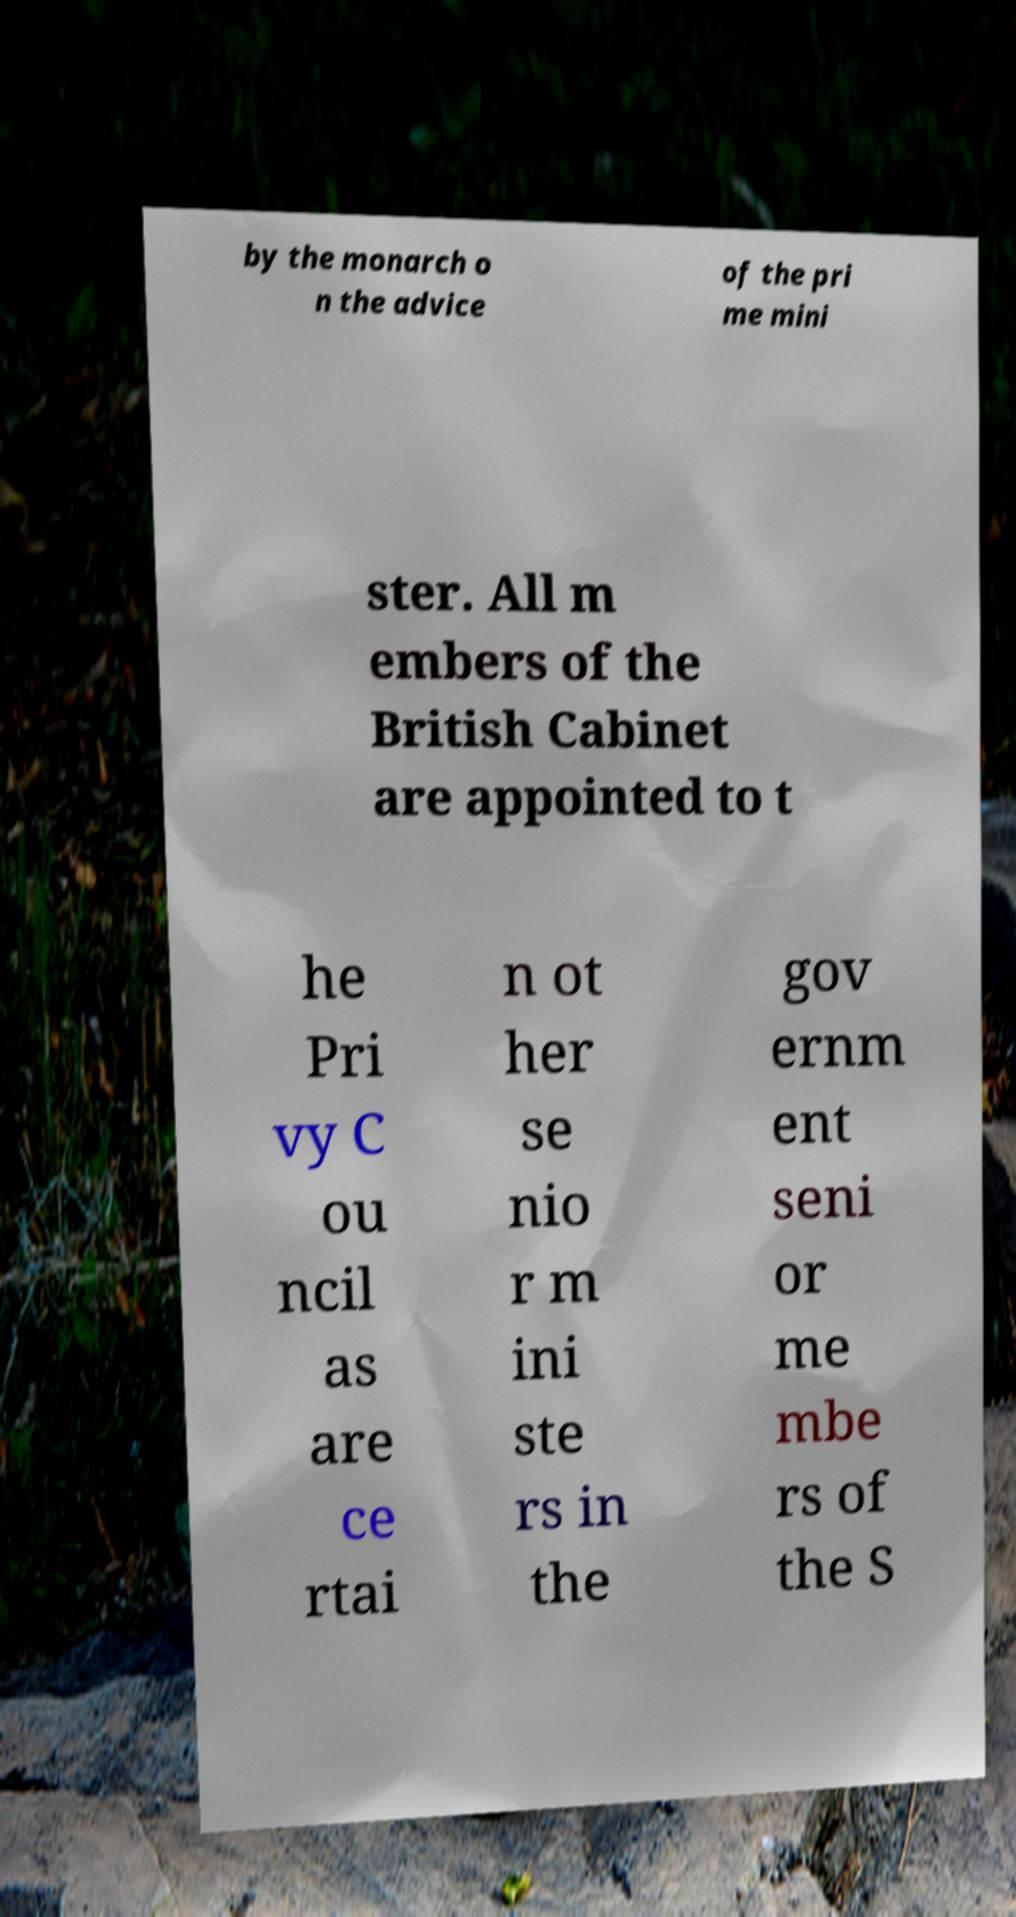Please read and relay the text visible in this image. What does it say? by the monarch o n the advice of the pri me mini ster. All m embers of the British Cabinet are appointed to t he Pri vy C ou ncil as are ce rtai n ot her se nio r m ini ste rs in the gov ernm ent seni or me mbe rs of the S 